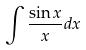Convert formula to latex. <formula><loc_0><loc_0><loc_500><loc_500>\int \frac { \sin x } { x } d x</formula> 